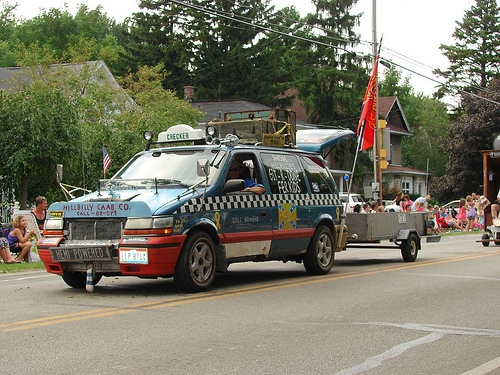<image>
Is there a flag to the left of the car? No. The flag is not to the left of the car. From this viewpoint, they have a different horizontal relationship. Where is the horns in relation to the man? Is it behind the man? No. The horns is not behind the man. From this viewpoint, the horns appears to be positioned elsewhere in the scene. 